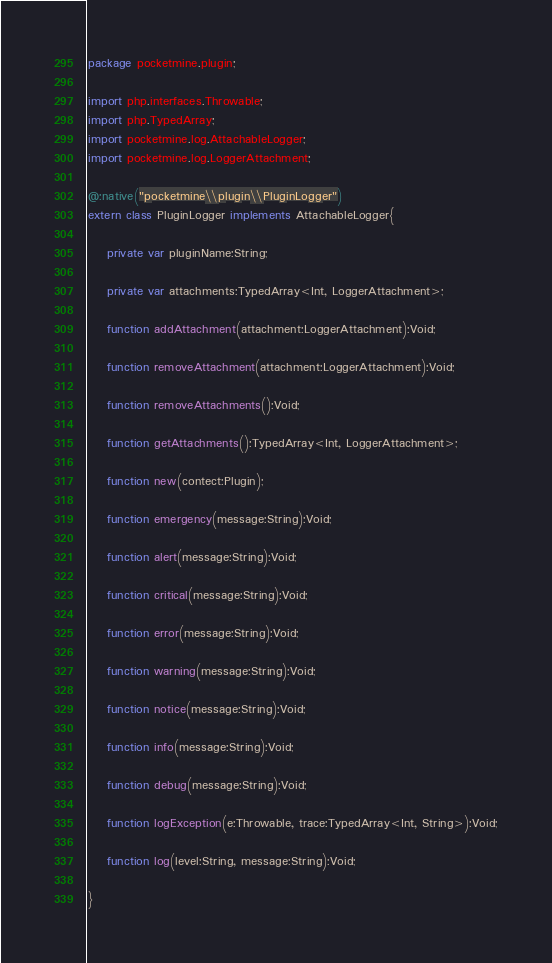Convert code to text. <code><loc_0><loc_0><loc_500><loc_500><_Haxe_>package pocketmine.plugin;

import php.interfaces.Throwable;
import php.TypedArray;
import pocketmine.log.AttachableLogger;
import pocketmine.log.LoggerAttachment;

@:native("pocketmine\\plugin\\PluginLogger")
extern class PluginLogger implements AttachableLogger{

    private var pluginName:String;

    private var attachments:TypedArray<Int, LoggerAttachment>;

    function addAttachment(attachment:LoggerAttachment):Void;

    function removeAttachment(attachment:LoggerAttachment):Void;

    function removeAttachments():Void;

    function getAttachments():TypedArray<Int, LoggerAttachment>;

    function new(contect:Plugin);

    function emergency(message:String):Void;

    function alert(message:String):Void;

    function critical(message:String):Void;

    function error(message:String):Void;

    function warning(message:String):Void;

    function notice(message:String):Void;

    function info(message:String):Void;

    function debug(message:String):Void;

    function logException(e:Throwable, trace:TypedArray<Int, String>):Void;

    function log(level:String, message:String):Void;

}
</code> 